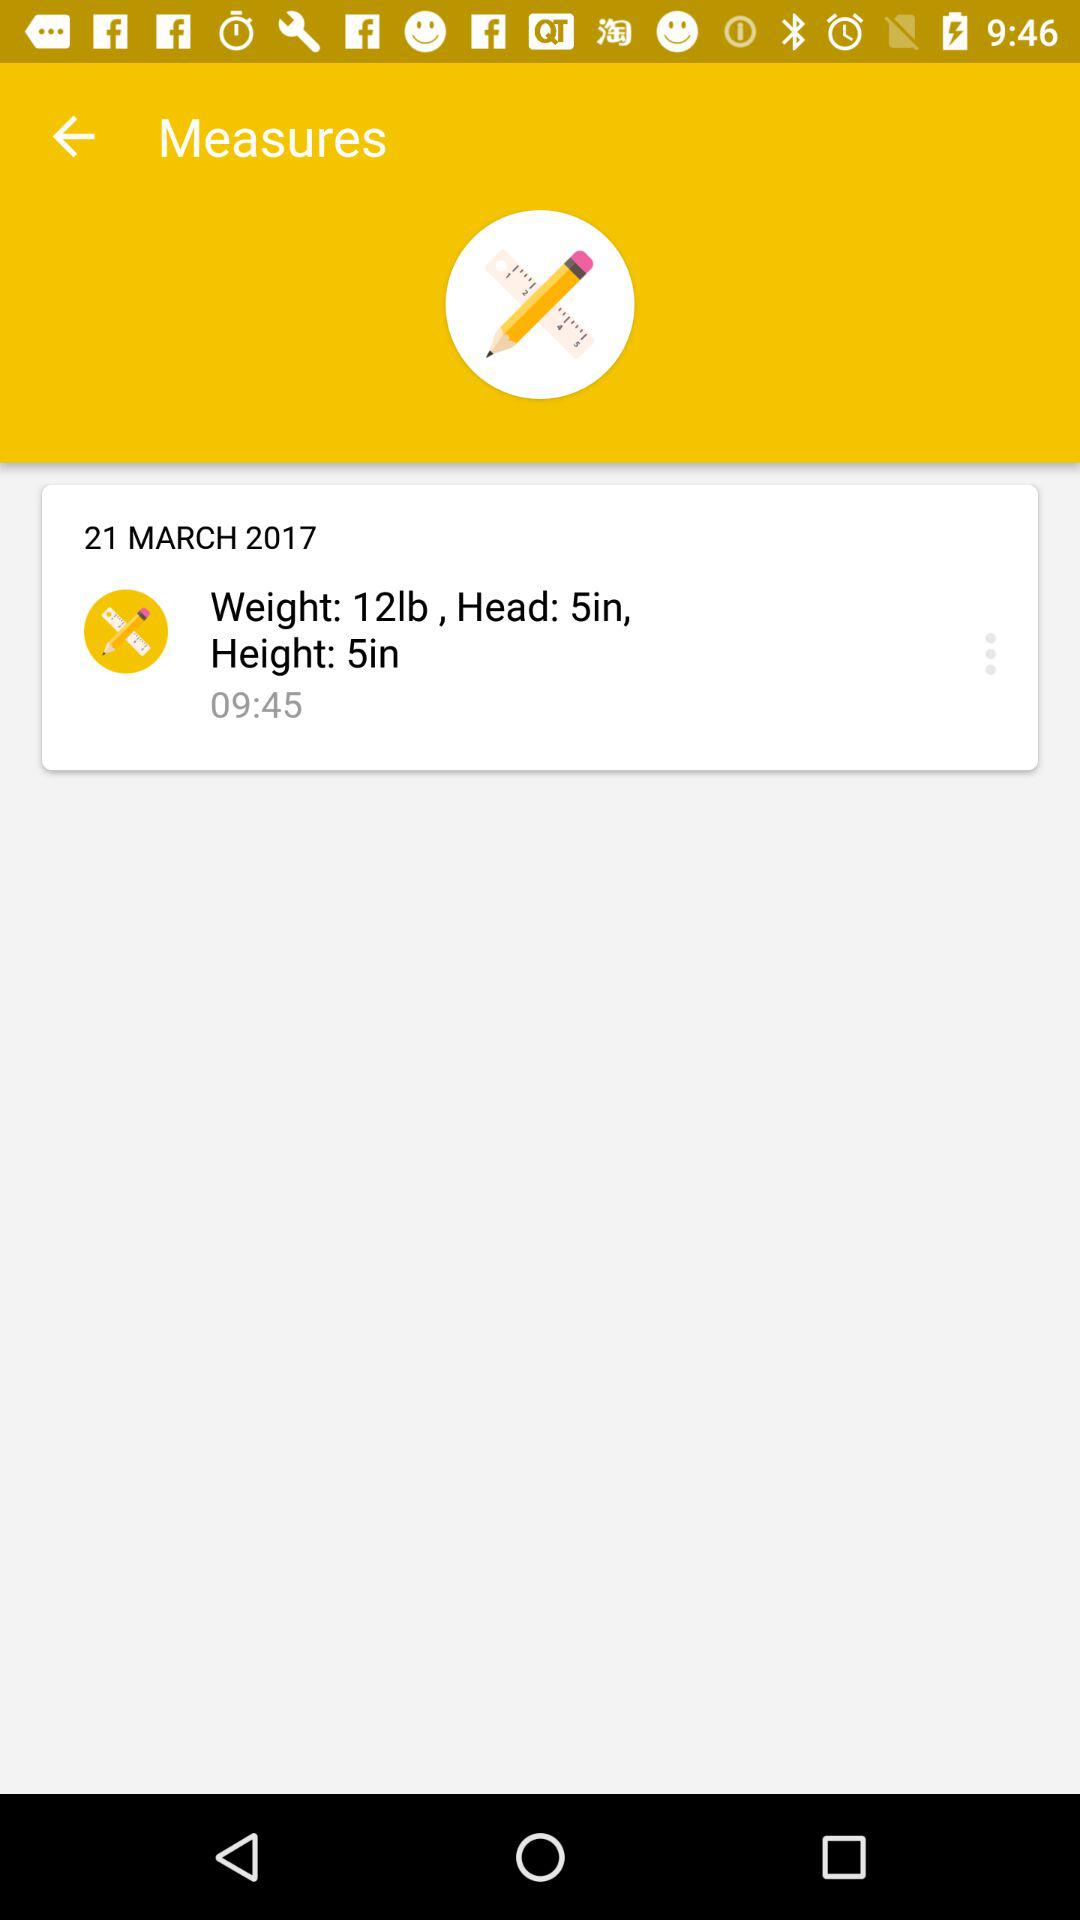What is the time of the measuring? The time of the measuring is 09:45. 